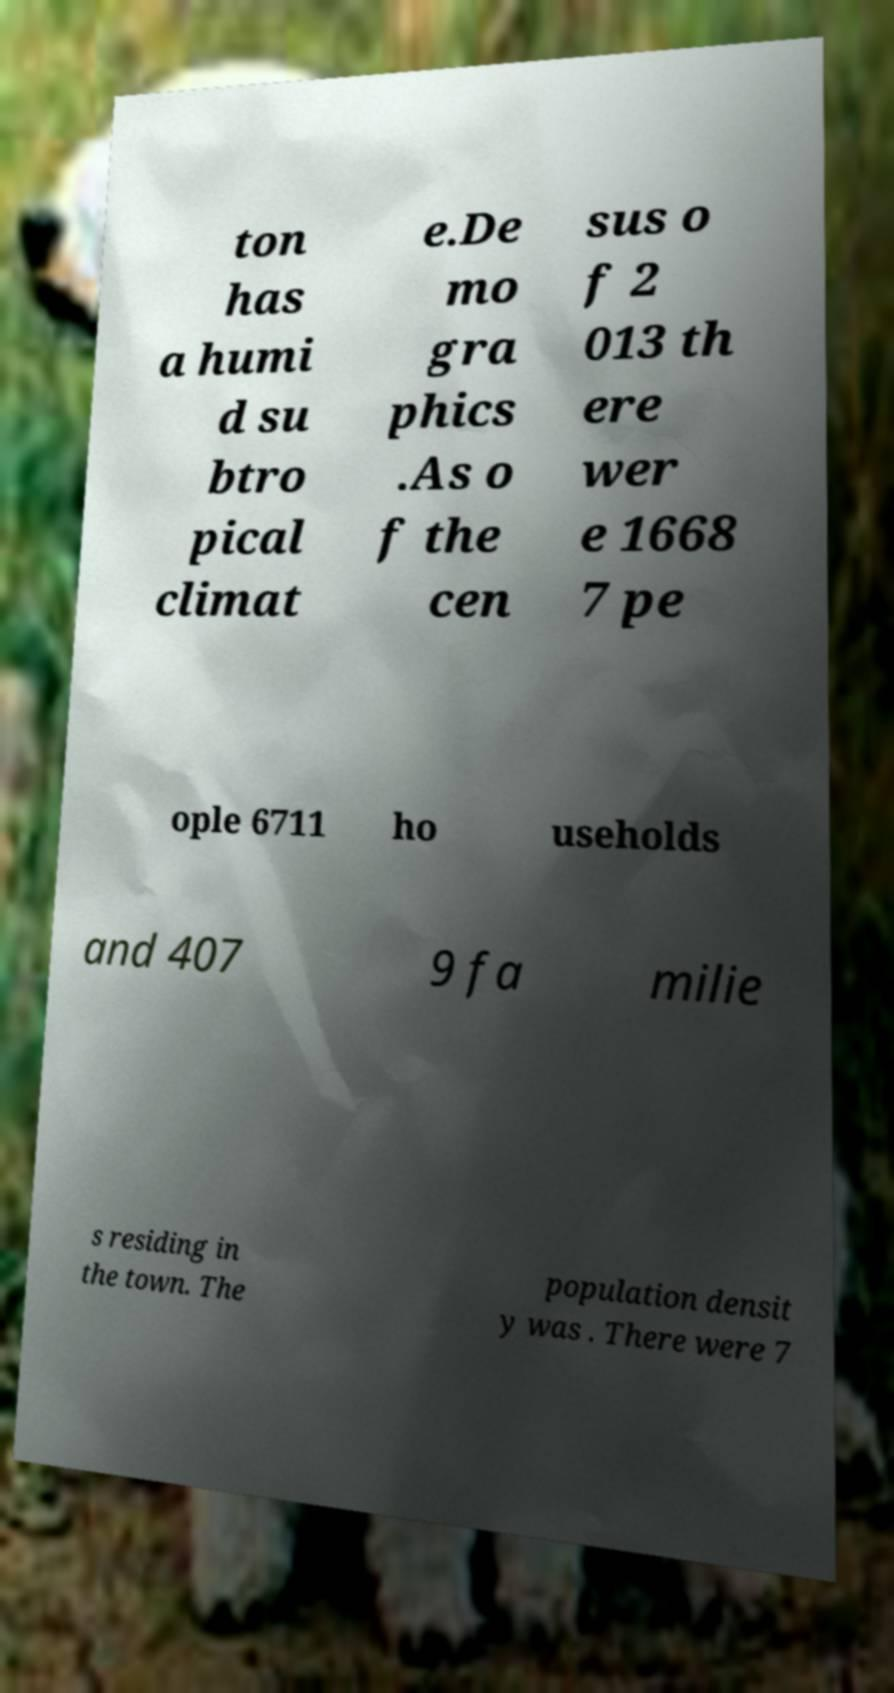Can you read and provide the text displayed in the image?This photo seems to have some interesting text. Can you extract and type it out for me? ton has a humi d su btro pical climat e.De mo gra phics .As o f the cen sus o f 2 013 th ere wer e 1668 7 pe ople 6711 ho useholds and 407 9 fa milie s residing in the town. The population densit y was . There were 7 